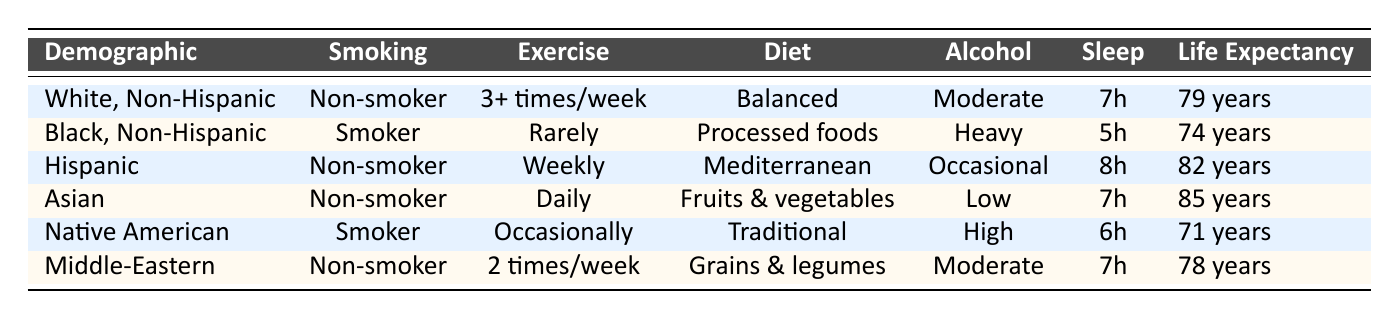What is the life expectancy of Hispanic individuals? The table specifies that the life expectancy for the Hispanic demographic is listed as 82 years.
Answer: 82 years Which demographic has the longest life expectancy? The table shows that the Asian demographic has the longest life expectancy at 85 years.
Answer: 85 years Is the smoking status of White, Non-Hispanic individuals non-smoker according to the table? Referring to the table, it is clear that White, Non-Hispanic individuals are categorized as non-smokers.
Answer: Yes What is the average life expectancy of smokers? We can focus on the smokers in the table, which are Black, Non-Hispanic and Native American, having life expectancies of 74 years and 71 years respectively. The average is (74 + 71) / 2 = 72.5.
Answer: 72.5 years Do any demographic groups report an average of less than 75 years life expectancy? Looking at the life expectancy figures for each group, both Black, Non-Hispanic (74 years) and Native American (71 years) are below 75 years.
Answer: Yes What is the difference in life expectancy between the Asian and Native American demographics? The life expectancy for the Asian demographic is 85 years, while the Native American demographic's life expectancy is 71 years. The difference is 85 - 71 = 14 years.
Answer: 14 years How many hours of sleep do Hispanic individuals report on average? According to the data, Hispanic individuals report 8 hours of sleep.
Answer: 8 hours Which lifestyle choice is associated with the highest life expectancy in the table? Analyzing the lifestyle choices associated with each demographic, the Asian demographic with a life expectancy of 85 years has the most favorable lifestyle choices: non-smoker, daily exercise, high fruit and vegetable diet, and low alcohol consumption.
Answer: Daily exercise, non-smoker status What is the combined sleep hours of Black, Non-Hispanic and Native American individuals? From the table, Black, Non-Hispanic individuals report 5 hours of sleep and Native American individuals report 6 hours of sleep. Therefore, total sleep hours = 5 + 6 = 11 hours.
Answer: 11 hours 